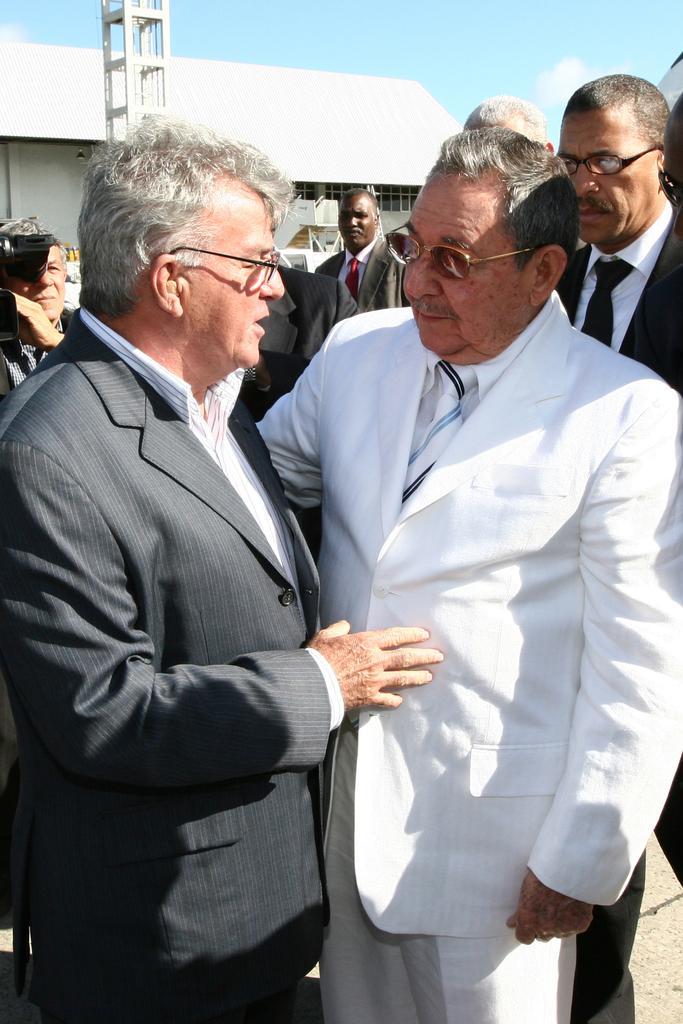Can you describe this image briefly? In the image there are few persons standing in suits talking and behind them its a building and above its sky with clouds. 